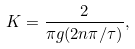<formula> <loc_0><loc_0><loc_500><loc_500>K = \frac { 2 } { \pi g ( 2 n \pi / \tau ) } ,</formula> 